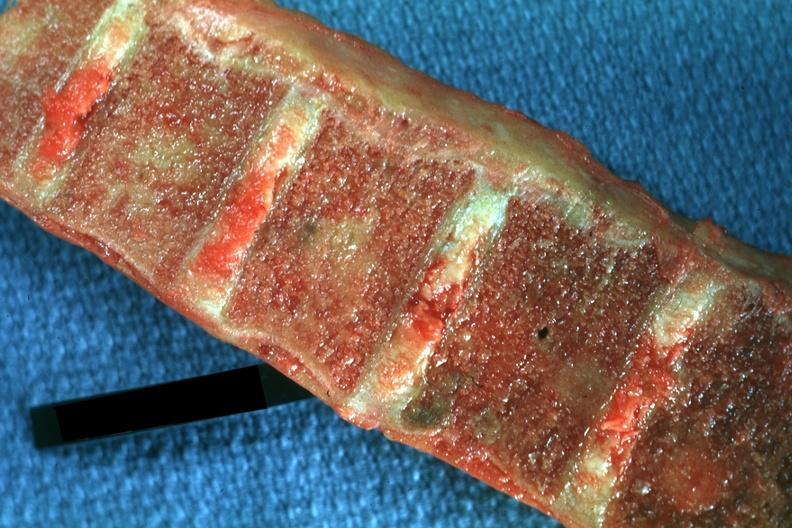s this image shows wrights typical present?
Answer the question using a single word or phrase. No 